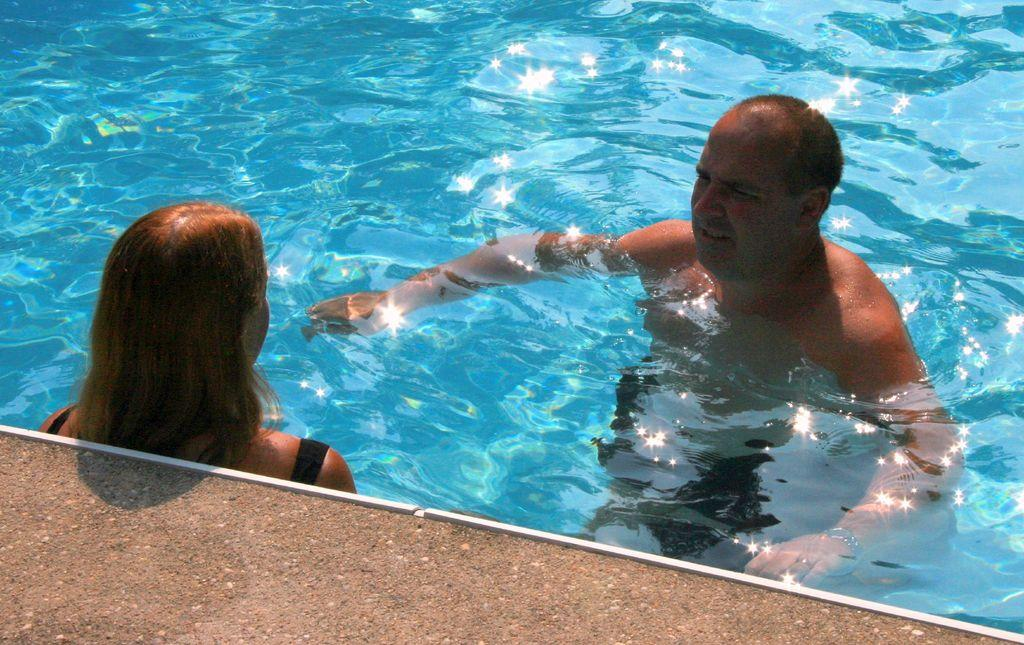What is the main feature in the picture? There is a swimming pool in the picture. What color is the swimming pool? The swimming pool is blue in color. What is inside the swimming pool? The swimming pool contains water. Are there any people in the swimming pool? Yes, there is a man and a woman in the swimming pool. What is located beside the swimming pool? There is a path beside the swimming pool. How many cups of tea are being served on the border of the swimming pool? There are no cups of tea or any indication of serving tea in the image. The image only features a swimming pool with people inside and a path beside it. 